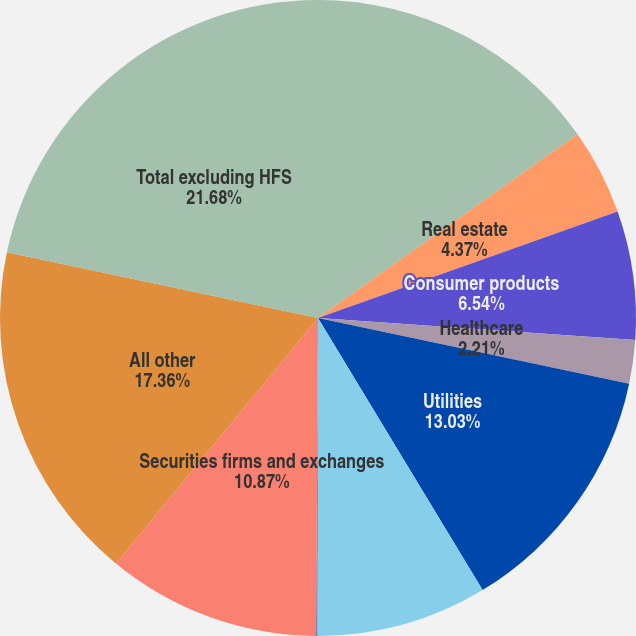Convert chart. <chart><loc_0><loc_0><loc_500><loc_500><pie_chart><fcel>Banks and finance companies<fcel>Real estate<fcel>Consumer products<fcel>Healthcare<fcel>Utilities<fcel>Oil and gas<fcel>Asset managers<fcel>Securities firms and exchanges<fcel>All other<fcel>Total excluding HFS<nl><fcel>15.19%<fcel>4.37%<fcel>6.54%<fcel>2.21%<fcel>13.03%<fcel>8.7%<fcel>0.05%<fcel>10.87%<fcel>17.36%<fcel>21.68%<nl></chart> 